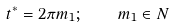Convert formula to latex. <formula><loc_0><loc_0><loc_500><loc_500>t ^ { * } = 2 \pi m _ { 1 } ; \quad m _ { 1 } \in N</formula> 